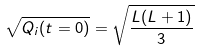<formula> <loc_0><loc_0><loc_500><loc_500>\sqrt { Q _ { i } ( t = 0 ) } = \sqrt { \frac { L ( L + 1 ) } { 3 } }</formula> 